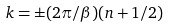Convert formula to latex. <formula><loc_0><loc_0><loc_500><loc_500>k = \pm ( 2 \pi / \beta ) ( n + 1 / 2 )</formula> 